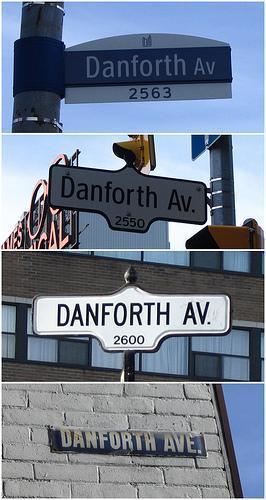How many signs do you see?
Give a very brief answer. 4. 